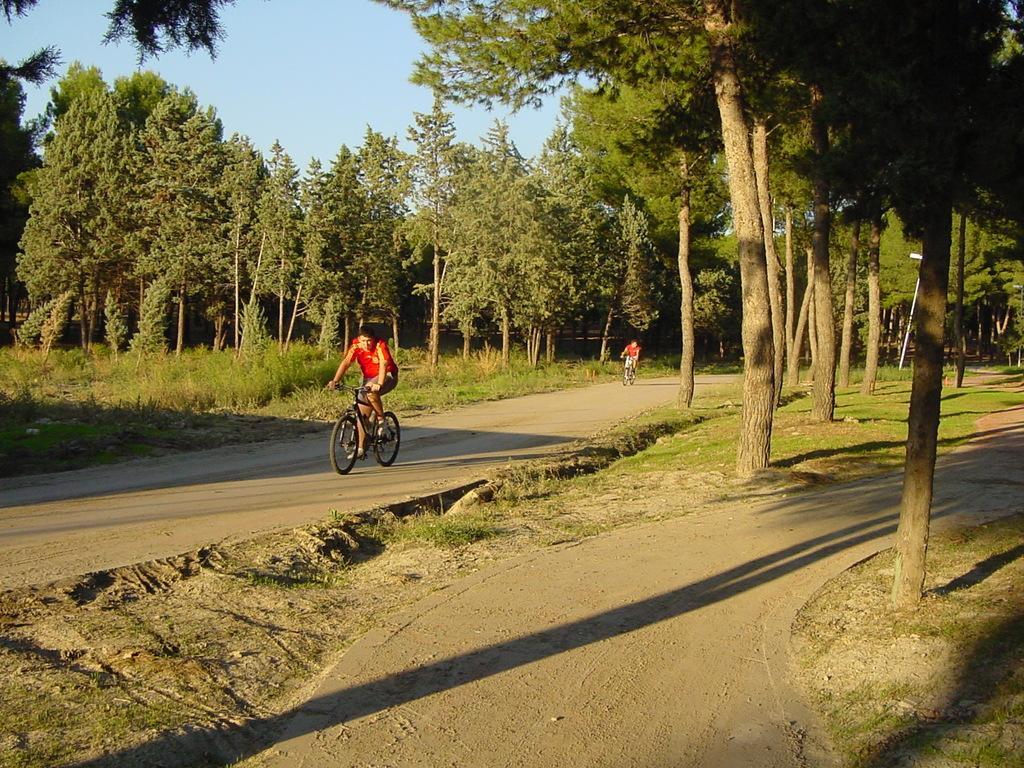How many people are in the image? There are two persons in the image. What are the two persons doing in the image? The two persons are riding on a bi-cycle. Where is the bi-cycle located? The bi-cycle is on a road. What can be seen in the background of the image? Trees, the sky, and grass are visible in the image. How many fans are visible in the image? There are no fans present in the image. What type of arch can be seen in the image? There is no arch present in the image. 